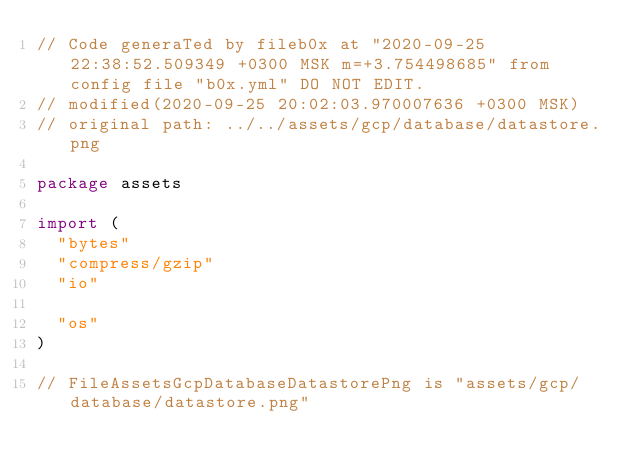<code> <loc_0><loc_0><loc_500><loc_500><_Go_>// Code generaTed by fileb0x at "2020-09-25 22:38:52.509349 +0300 MSK m=+3.754498685" from config file "b0x.yml" DO NOT EDIT.
// modified(2020-09-25 20:02:03.970007636 +0300 MSK)
// original path: ../../assets/gcp/database/datastore.png

package assets

import (
	"bytes"
	"compress/gzip"
	"io"

	"os"
)

// FileAssetsGcpDatabaseDatastorePng is "assets/gcp/database/datastore.png"</code> 